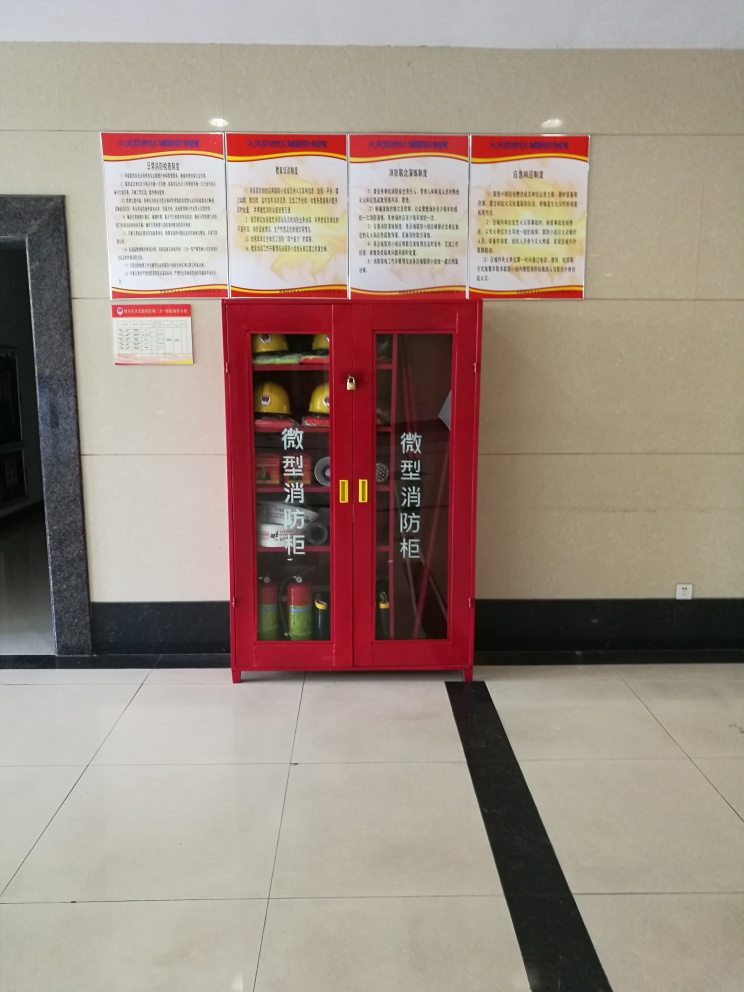What information might the signs above the cabinet convey? The signs above the cabinet are likely to contain fire safety instructions, evacuation procedures, and guidelines on how to use the equipment stored in the cabinet. These signs are crucial for providing direction and knowledge to people during an emergency. 